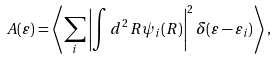Convert formula to latex. <formula><loc_0><loc_0><loc_500><loc_500>A ( \varepsilon ) = \left \langle \sum _ { i } \left | \int d ^ { 2 } \, R \psi _ { i } ( R ) \right | ^ { 2 } \delta ( \varepsilon - \varepsilon _ { i } ) \right \rangle ,</formula> 